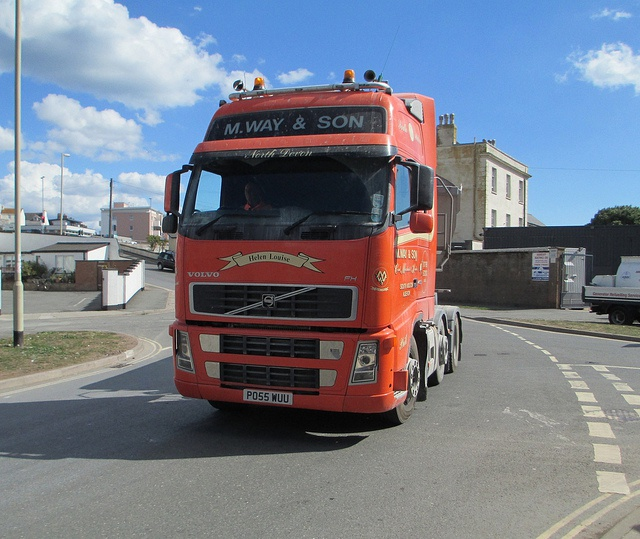Describe the objects in this image and their specific colors. I can see truck in lightblue, black, maroon, gray, and salmon tones, truck in lightblue, black, and gray tones, people in black, maroon, brown, and lightblue tones, car in lightblue, black, gray, and darkblue tones, and car in lightblue, darkgray, and lightgray tones in this image. 